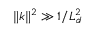<formula> <loc_0><loc_0><loc_500><loc_500>\| k \| ^ { 2 } \gg 1 / L _ { d } ^ { 2 }</formula> 